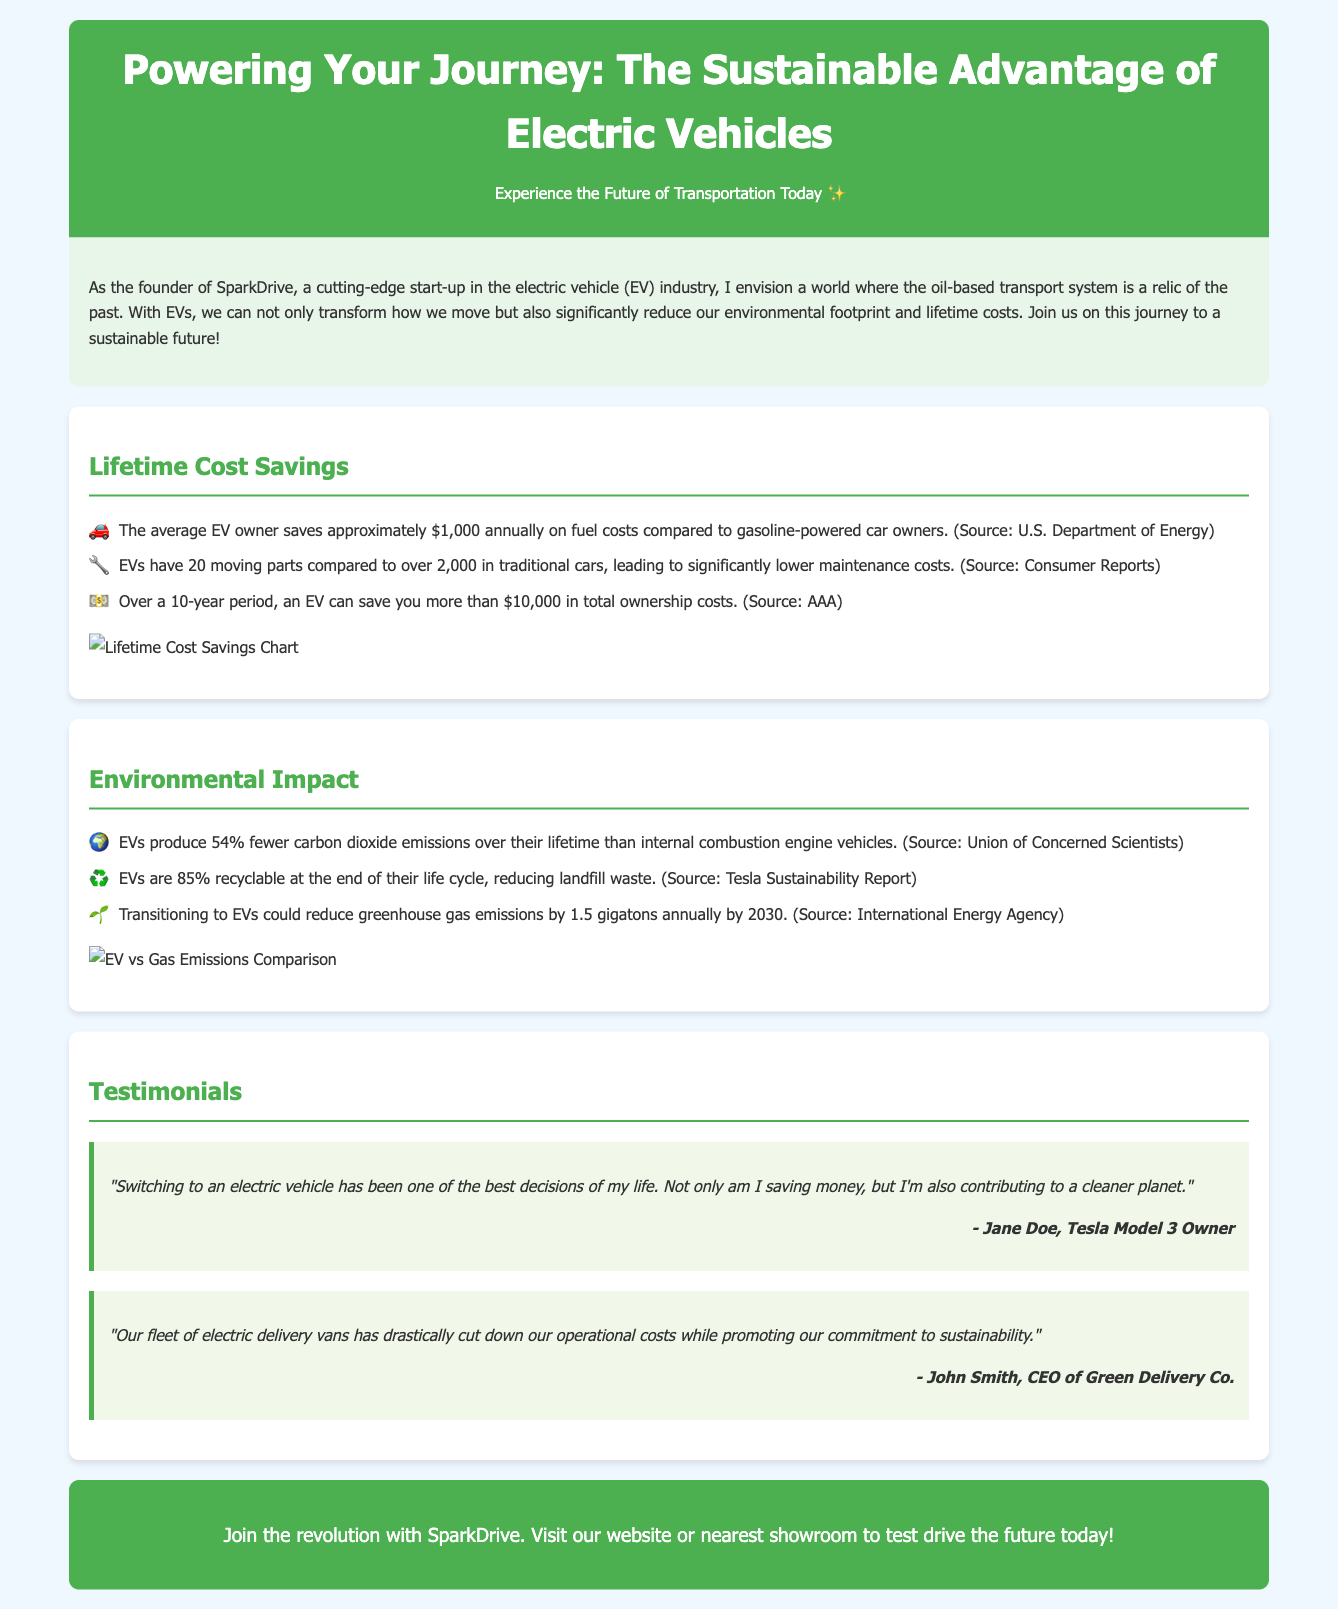what is the average annual savings for an EV owner? The document states that the average EV owner saves approximately $1,000 annually on fuel costs compared to gasoline-powered car owners.
Answer: $1,000 how many moving parts do EVs have? According to the document, EVs have 20 moving parts compared to over 2,000 in traditional cars.
Answer: 20 moving parts what is the total ownership cost savings over 10 years for an EV? The advertisement mentions that over a 10-year period, an EV can save you more than $10,000 in total ownership costs.
Answer: more than $10,000 by what percentage do EVs reduce carbon dioxide emissions compared to gasoline vehicles? The document states that EVs produce 54% fewer carbon dioxide emissions over their lifetime than internal combustion engine vehicles.
Answer: 54% how much can transitioning to EVs reduce greenhouse gas emissions by 2030? The advertisement indicates that transitioning to EVs could reduce greenhouse gas emissions by 1.5 gigatons annually by 2030.
Answer: 1.5 gigatons who is a Tesla Model 3 owner mentioned in the testimonials? The testimonial includes a quote from Jane Doe, who is identified as a Tesla Model 3 owner.
Answer: Jane Doe which company’s CEO is quoted in the testimonials section? The CEO of Green Delivery Co. is quoted in the testimonials section.
Answer: Green Delivery Co what percentage of EVs are recyclable at the end of their life cycle? The document specifies that EVs are 85% recyclable at the end of their life cycle.
Answer: 85% what is the main call to action in the document? The call to action encourages readers to join the revolution with SparkDrive and to visit their website or showroom.
Answer: Join the revolution with SparkDrive 